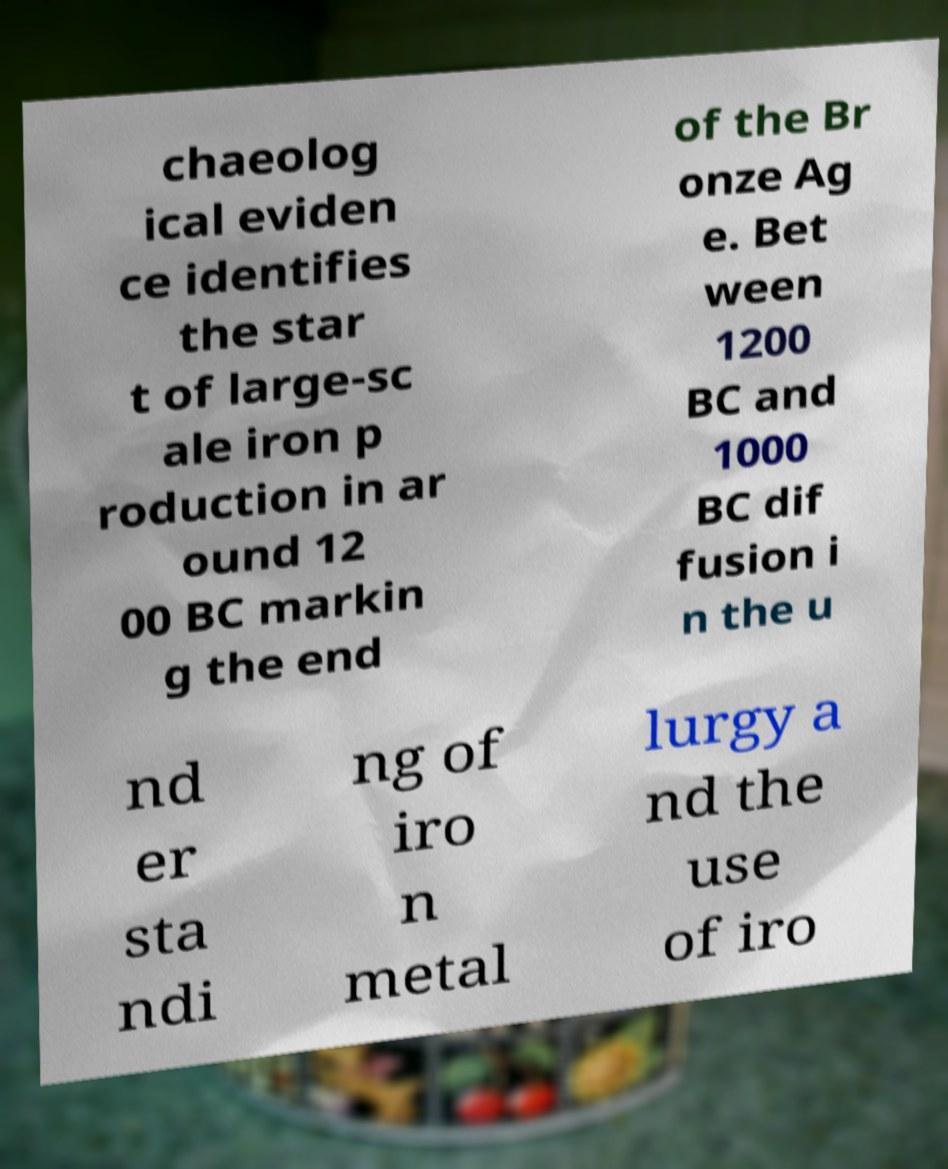I need the written content from this picture converted into text. Can you do that? chaeolog ical eviden ce identifies the star t of large-sc ale iron p roduction in ar ound 12 00 BC markin g the end of the Br onze Ag e. Bet ween 1200 BC and 1000 BC dif fusion i n the u nd er sta ndi ng of iro n metal lurgy a nd the use of iro 